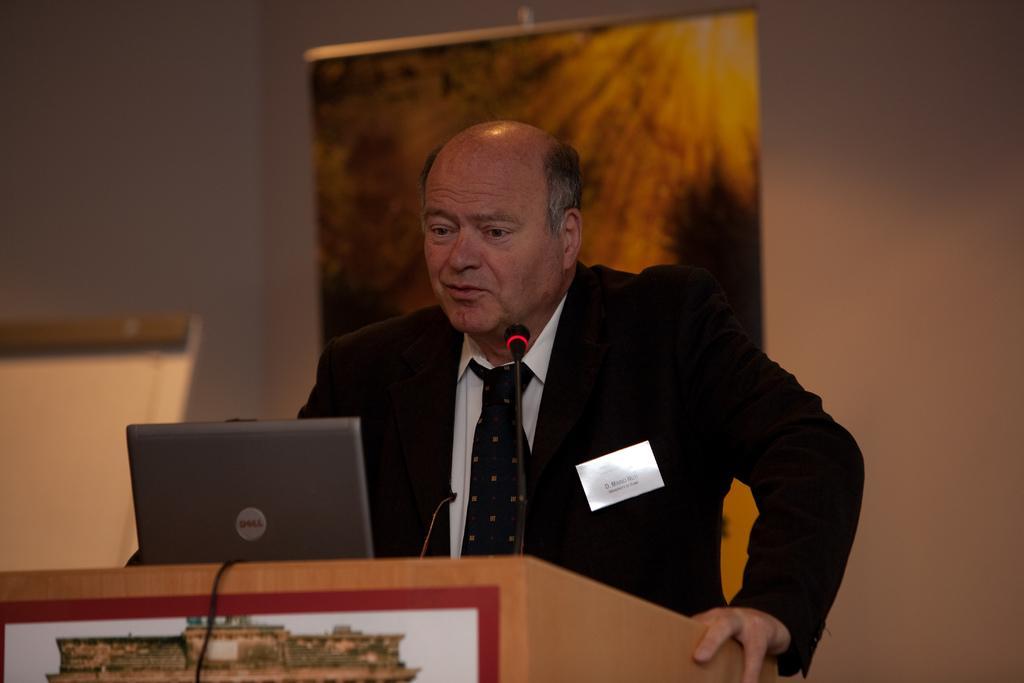Please provide a concise description of this image. Here we can see a man standing at the podium. On the podium we can see a laptop and a microphone. In the background we can see a wall,hoarding and an object. 